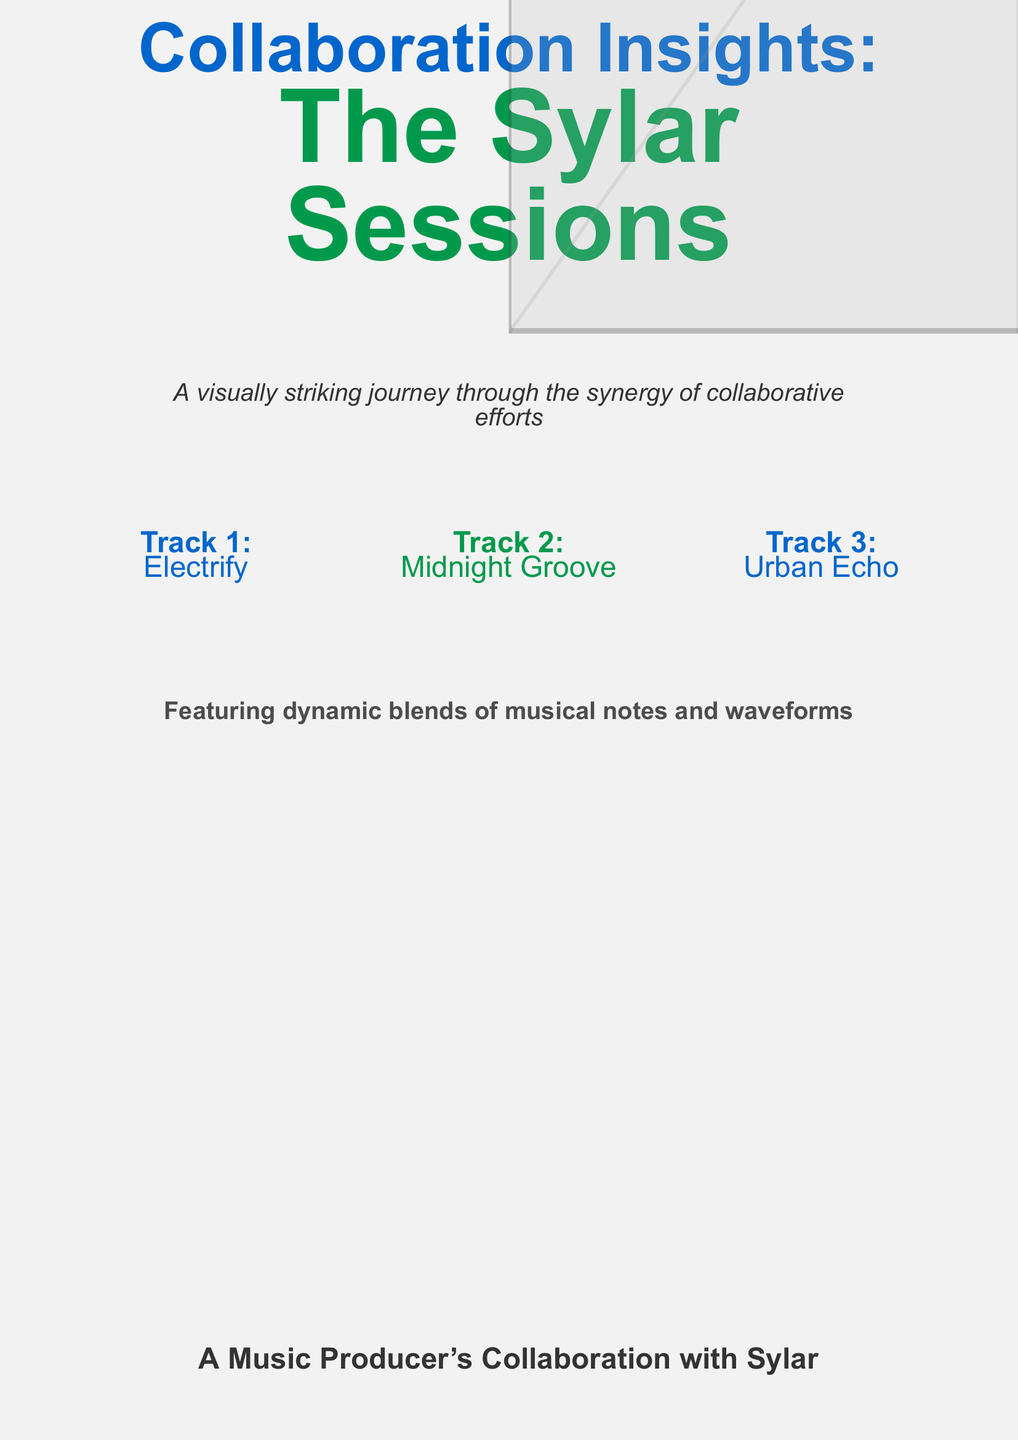What is the title of the book? The title is prominently displayed in large font on the cover.
Answer: The Sylar Sessions How many tracks are featured on the cover? The cover lists three tracks in the multicols section.
Answer: Three What is the color used for the title text? The main title features two different colors, one of which is specified.
Answer: Sylar blue What is the subtitle of the book? The subtitle is located underneath the main title, providing additional context.
Answer: Collaboration Insights What is the theme of the cover design? The cover design incorporates specific visual elements relating to music production and collaboration.
Answer: Synergy of collaborative efforts Which track is listed first on the cover? The first track appears in the first column of the multicols section.
Answer: Electrify What visual elements are used in the cover backdrop? The backdrop features an artistic representation that complements the theme.
Answer: Musical notes and waveforms What type of visual effect is used in the cover design? The cover utilizes a stylistic approach that involves multiple layers of images and colors.
Answer: Layered collage effect What kind of journey does the cover describe? The text describes the overall experience encapsulated within the collaborative music production.
Answer: Visually striking journey 